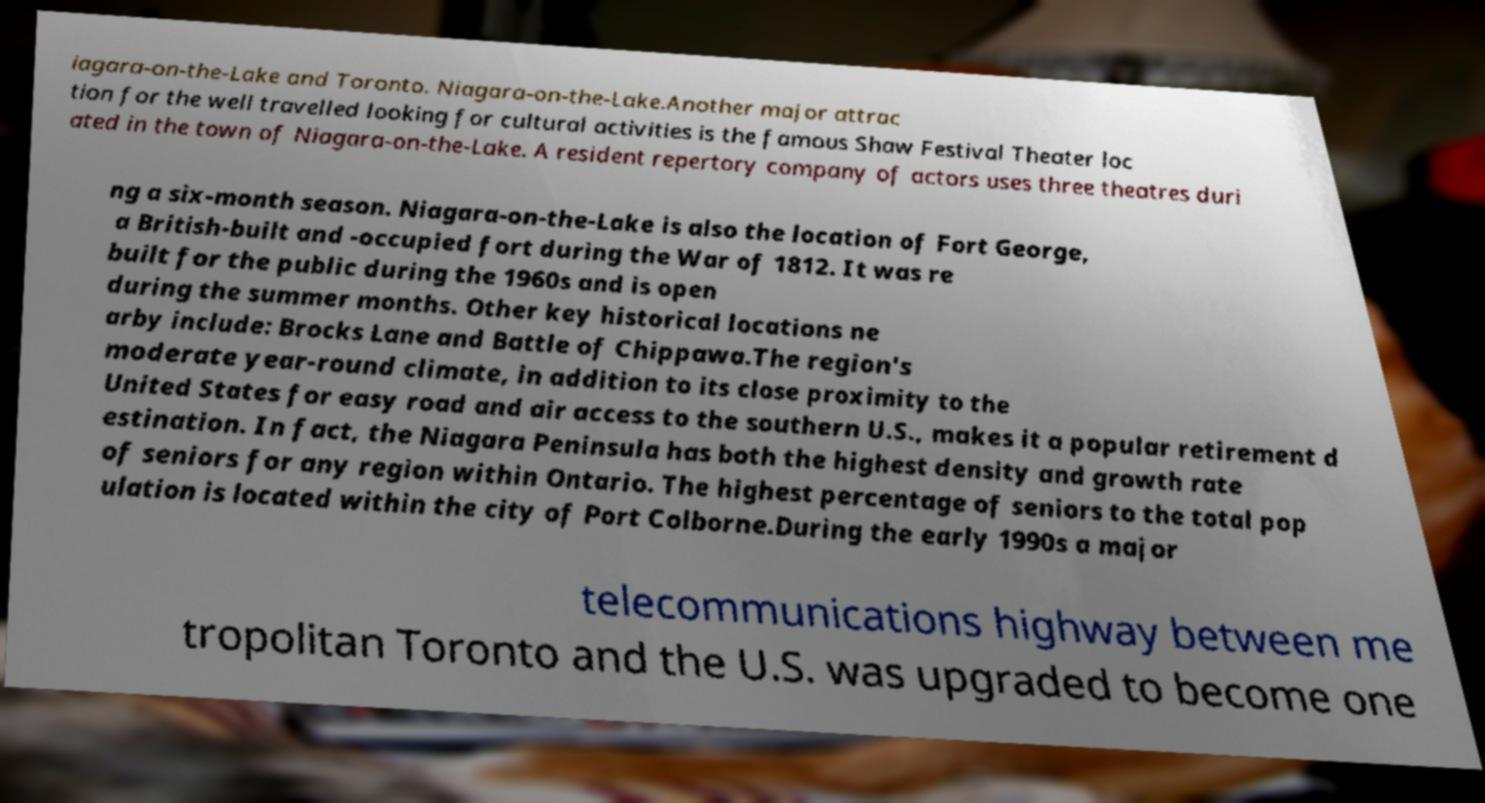Can you accurately transcribe the text from the provided image for me? iagara-on-the-Lake and Toronto. Niagara-on-the-Lake.Another major attrac tion for the well travelled looking for cultural activities is the famous Shaw Festival Theater loc ated in the town of Niagara-on-the-Lake. A resident repertory company of actors uses three theatres duri ng a six-month season. Niagara-on-the-Lake is also the location of Fort George, a British-built and -occupied fort during the War of 1812. It was re built for the public during the 1960s and is open during the summer months. Other key historical locations ne arby include: Brocks Lane and Battle of Chippawa.The region's moderate year-round climate, in addition to its close proximity to the United States for easy road and air access to the southern U.S., makes it a popular retirement d estination. In fact, the Niagara Peninsula has both the highest density and growth rate of seniors for any region within Ontario. The highest percentage of seniors to the total pop ulation is located within the city of Port Colborne.During the early 1990s a major telecommunications highway between me tropolitan Toronto and the U.S. was upgraded to become one 